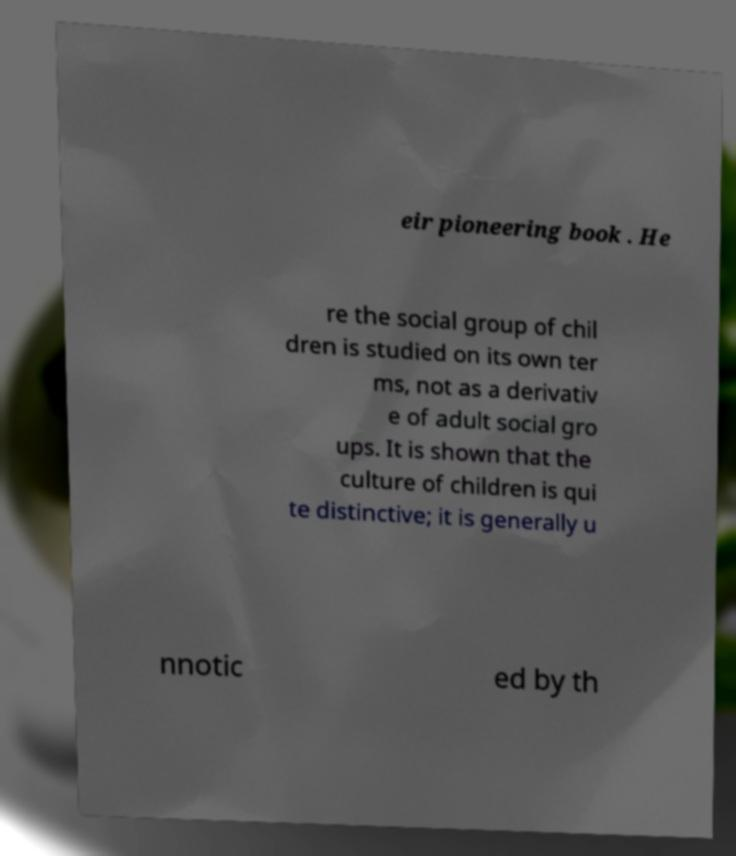I need the written content from this picture converted into text. Can you do that? eir pioneering book . He re the social group of chil dren is studied on its own ter ms, not as a derivativ e of adult social gro ups. It is shown that the culture of children is qui te distinctive; it is generally u nnotic ed by th 